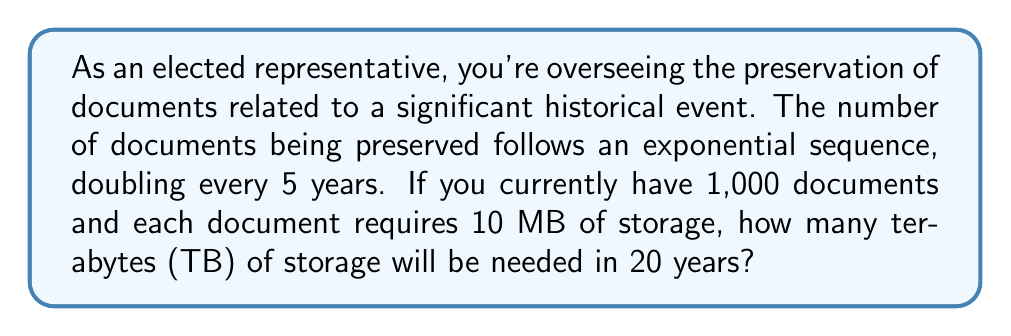Give your solution to this math problem. Let's approach this step-by-step:

1) First, we need to determine how many times the number of documents will double in 20 years:
   $\frac{20 \text{ years}}{5 \text{ years per doubling}} = 4$ doublings

2) Now, let's calculate the number of documents after 20 years:
   $1,000 \times 2^4 = 1,000 \times 16 = 16,000$ documents

3) Each document requires 10 MB of storage, so the total storage needed in MB is:
   $16,000 \times 10 \text{ MB} = 160,000 \text{ MB}$

4) To convert MB to TB, we need to divide by $1,024^2$ (since 1 TB = 1,024 GB = 1,024^2 MB):
   
   $$\frac{160,000 \text{ MB}}{1,024^2 \text{ MB/TB}} = \frac{160,000}{1,048,576} \approx 0.1526 \text{ TB}$$

5) Rounding to two decimal places:
   $0.15 \text{ TB}$
Answer: 0.15 TB 